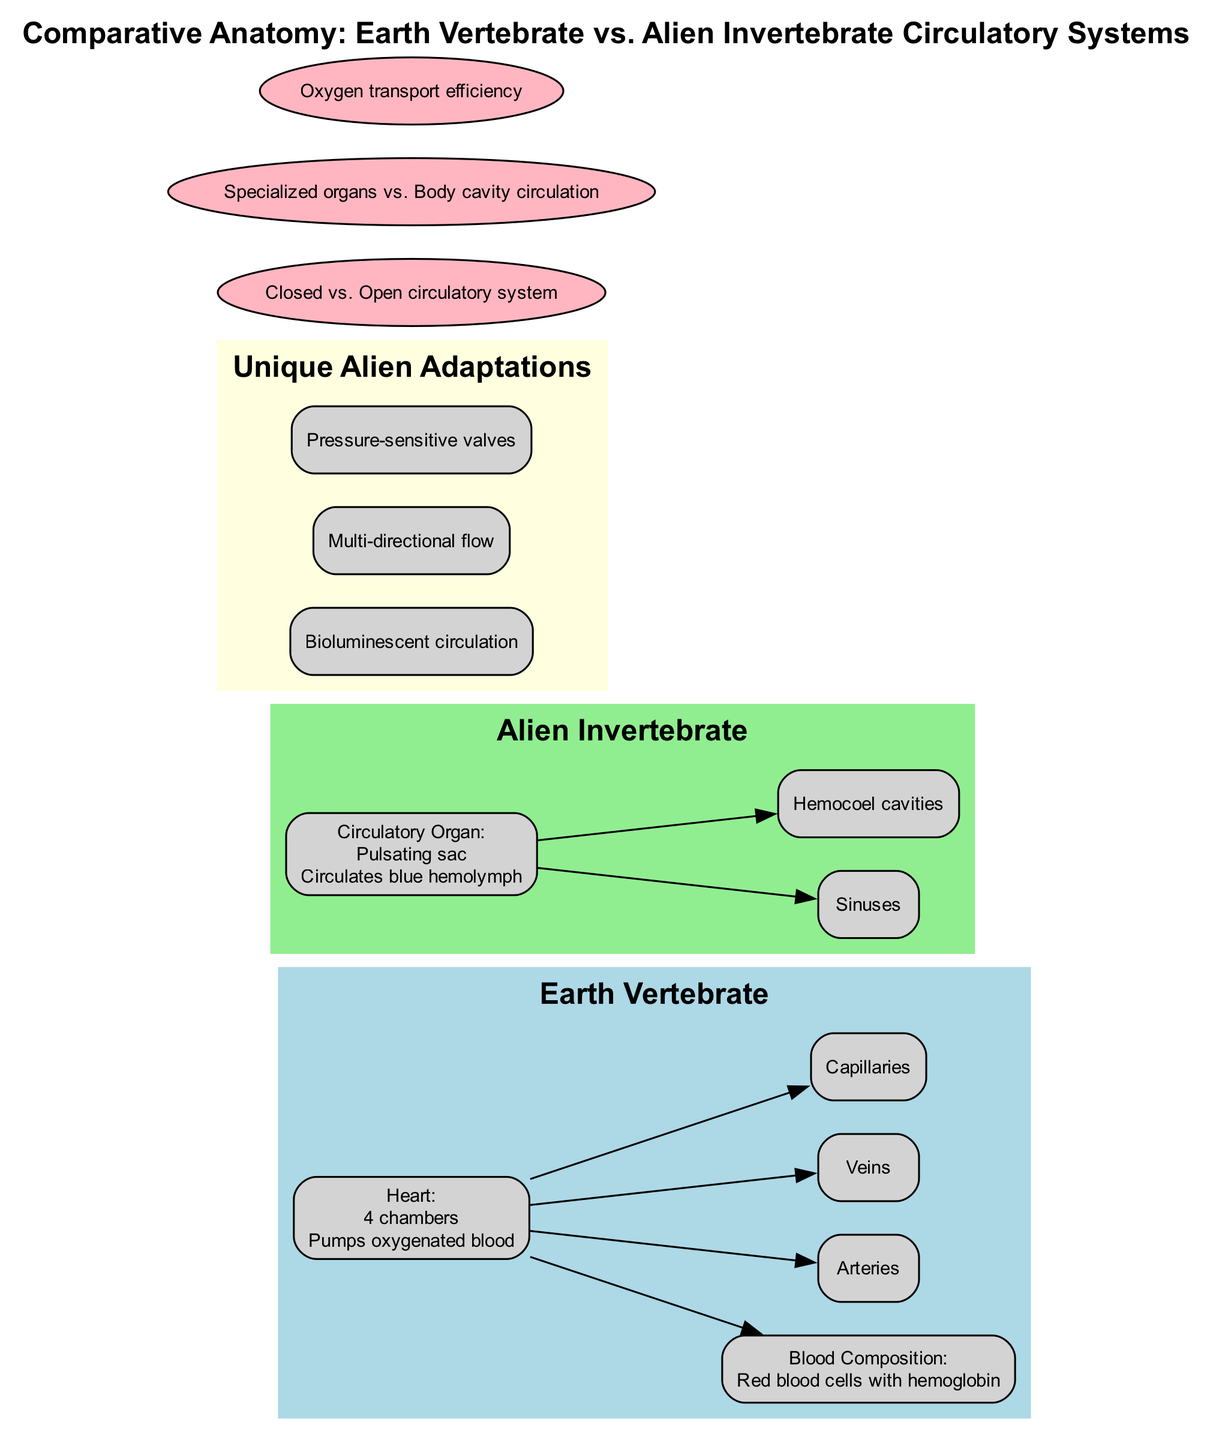What is the number of chambers in the Earth vertebrate heart? The diagram specifies that the Earth vertebrate heart has "4 chambers". Therefore, counting the specified chambers gives the answer.
Answer: 4 chambers What type of blood do Earth vertebrates have? According to the diagram, the "Blood Composition" for Earth vertebrates states "Red blood cells with hemoglobin". This indicates the type of blood present.
Answer: Red blood cells with hemoglobin What is the circulatory organ of the alien invertebrate? The diagram identifies the "Circulatory Organ" for the alien invertebrate as "Pulsating sac", providing a direct reference to that specific part.
Answer: Pulsating sac How many unique adaptations are listed for the alien invertebrate circulatory system? The diagram showcases three unique adaptations for the alien of which they are "Bioluminescent circulation", "Multi-directional flow", and "Pressure-sensitive valves". Counting these adaptations gives us the answer.
Answer: 3 What distinguishes the Earth vertebrate's circulatory system from the alien invertebrate's system? The diagram portrays a comparison, stating "Closed vs. Open circulatory system". This highlights the fundamental differences between the two systems.
Answer: Closed vs. Open circulatory system What is the function of the pulsating sac? The diagram specifies the function of the "Pulsating sac" in the alien invertebrate as "Circulates blue hemolymph". This succinctly reveals its purpose.
Answer: Circulates blue hemolymph What blood vessels are associated with the Earth vertebrate system? The expected blood vessels are listed in the diagram as "Arteries", "Veins", and "Capillaries". Thus, summarizing these provides the relevant information.
Answer: Arteries, Veins, Capillaries Which fluid channels are present in the alien invertebrate's circulatory system? The diagram shows that the fluid channels include "Sinuses" and "Hemocoel cavities". This can be confirmed directly from the listed information.
Answer: Sinuses, Hemocoel cavities 